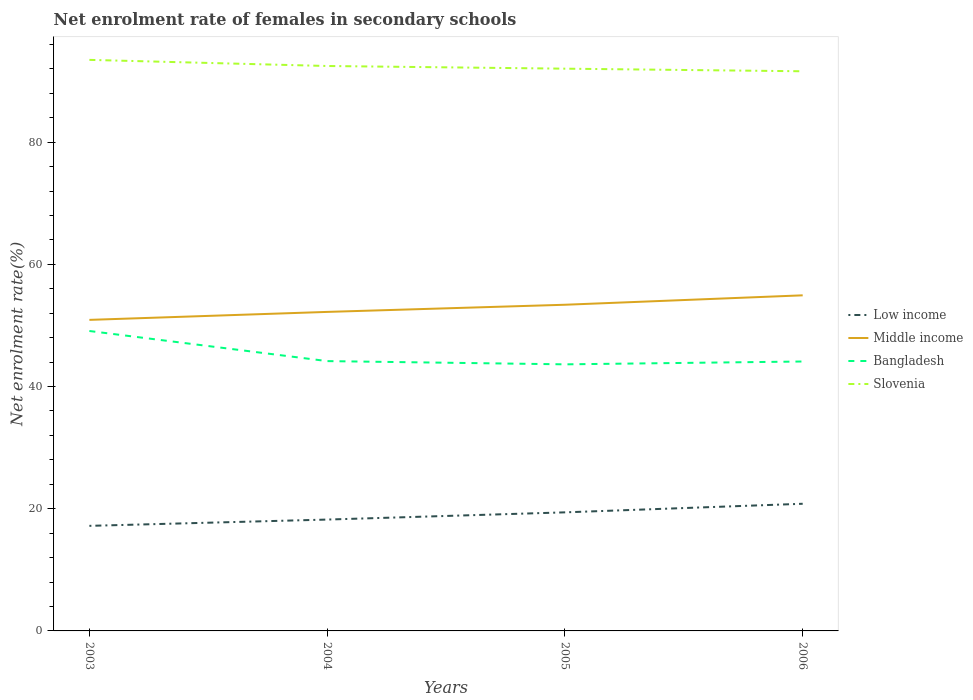Is the number of lines equal to the number of legend labels?
Your response must be concise. Yes. Across all years, what is the maximum net enrolment rate of females in secondary schools in Low income?
Offer a terse response. 17.2. In which year was the net enrolment rate of females in secondary schools in Slovenia maximum?
Your answer should be compact. 2006. What is the total net enrolment rate of females in secondary schools in Bangladesh in the graph?
Give a very brief answer. -0.46. What is the difference between the highest and the second highest net enrolment rate of females in secondary schools in Low income?
Make the answer very short. 3.61. What is the difference between the highest and the lowest net enrolment rate of females in secondary schools in Bangladesh?
Make the answer very short. 1. Is the net enrolment rate of females in secondary schools in Middle income strictly greater than the net enrolment rate of females in secondary schools in Bangladesh over the years?
Your response must be concise. No. How many lines are there?
Your response must be concise. 4. How many years are there in the graph?
Your response must be concise. 4. What is the difference between two consecutive major ticks on the Y-axis?
Ensure brevity in your answer.  20. Does the graph contain grids?
Offer a terse response. No. What is the title of the graph?
Make the answer very short. Net enrolment rate of females in secondary schools. What is the label or title of the Y-axis?
Provide a short and direct response. Net enrolment rate(%). What is the Net enrolment rate(%) in Low income in 2003?
Offer a terse response. 17.2. What is the Net enrolment rate(%) of Middle income in 2003?
Your response must be concise. 50.91. What is the Net enrolment rate(%) in Bangladesh in 2003?
Offer a terse response. 49.09. What is the Net enrolment rate(%) of Slovenia in 2003?
Keep it short and to the point. 93.46. What is the Net enrolment rate(%) of Low income in 2004?
Offer a terse response. 18.23. What is the Net enrolment rate(%) of Middle income in 2004?
Your answer should be very brief. 52.21. What is the Net enrolment rate(%) in Bangladesh in 2004?
Make the answer very short. 44.16. What is the Net enrolment rate(%) in Slovenia in 2004?
Provide a succinct answer. 92.46. What is the Net enrolment rate(%) in Low income in 2005?
Provide a succinct answer. 19.41. What is the Net enrolment rate(%) in Middle income in 2005?
Give a very brief answer. 53.38. What is the Net enrolment rate(%) of Bangladesh in 2005?
Offer a very short reply. 43.63. What is the Net enrolment rate(%) in Slovenia in 2005?
Offer a very short reply. 92.02. What is the Net enrolment rate(%) in Low income in 2006?
Make the answer very short. 20.81. What is the Net enrolment rate(%) of Middle income in 2006?
Keep it short and to the point. 54.93. What is the Net enrolment rate(%) in Bangladesh in 2006?
Your response must be concise. 44.1. What is the Net enrolment rate(%) of Slovenia in 2006?
Keep it short and to the point. 91.6. Across all years, what is the maximum Net enrolment rate(%) of Low income?
Offer a very short reply. 20.81. Across all years, what is the maximum Net enrolment rate(%) of Middle income?
Make the answer very short. 54.93. Across all years, what is the maximum Net enrolment rate(%) in Bangladesh?
Your response must be concise. 49.09. Across all years, what is the maximum Net enrolment rate(%) in Slovenia?
Your answer should be compact. 93.46. Across all years, what is the minimum Net enrolment rate(%) in Low income?
Provide a short and direct response. 17.2. Across all years, what is the minimum Net enrolment rate(%) in Middle income?
Your response must be concise. 50.91. Across all years, what is the minimum Net enrolment rate(%) of Bangladesh?
Your answer should be compact. 43.63. Across all years, what is the minimum Net enrolment rate(%) in Slovenia?
Provide a short and direct response. 91.6. What is the total Net enrolment rate(%) of Low income in the graph?
Provide a short and direct response. 75.64. What is the total Net enrolment rate(%) of Middle income in the graph?
Keep it short and to the point. 211.43. What is the total Net enrolment rate(%) in Bangladesh in the graph?
Offer a terse response. 180.98. What is the total Net enrolment rate(%) in Slovenia in the graph?
Provide a short and direct response. 369.54. What is the difference between the Net enrolment rate(%) of Low income in 2003 and that in 2004?
Your answer should be very brief. -1.03. What is the difference between the Net enrolment rate(%) in Middle income in 2003 and that in 2004?
Your response must be concise. -1.3. What is the difference between the Net enrolment rate(%) of Bangladesh in 2003 and that in 2004?
Make the answer very short. 4.93. What is the difference between the Net enrolment rate(%) in Slovenia in 2003 and that in 2004?
Keep it short and to the point. 1. What is the difference between the Net enrolment rate(%) in Low income in 2003 and that in 2005?
Ensure brevity in your answer.  -2.21. What is the difference between the Net enrolment rate(%) in Middle income in 2003 and that in 2005?
Your response must be concise. -2.48. What is the difference between the Net enrolment rate(%) of Bangladesh in 2003 and that in 2005?
Ensure brevity in your answer.  5.46. What is the difference between the Net enrolment rate(%) in Slovenia in 2003 and that in 2005?
Make the answer very short. 1.44. What is the difference between the Net enrolment rate(%) in Low income in 2003 and that in 2006?
Ensure brevity in your answer.  -3.61. What is the difference between the Net enrolment rate(%) of Middle income in 2003 and that in 2006?
Your answer should be very brief. -4.02. What is the difference between the Net enrolment rate(%) in Bangladesh in 2003 and that in 2006?
Make the answer very short. 4.99. What is the difference between the Net enrolment rate(%) in Slovenia in 2003 and that in 2006?
Make the answer very short. 1.87. What is the difference between the Net enrolment rate(%) in Low income in 2004 and that in 2005?
Ensure brevity in your answer.  -1.18. What is the difference between the Net enrolment rate(%) in Middle income in 2004 and that in 2005?
Keep it short and to the point. -1.17. What is the difference between the Net enrolment rate(%) in Bangladesh in 2004 and that in 2005?
Offer a very short reply. 0.53. What is the difference between the Net enrolment rate(%) of Slovenia in 2004 and that in 2005?
Keep it short and to the point. 0.44. What is the difference between the Net enrolment rate(%) in Low income in 2004 and that in 2006?
Keep it short and to the point. -2.59. What is the difference between the Net enrolment rate(%) in Middle income in 2004 and that in 2006?
Offer a very short reply. -2.71. What is the difference between the Net enrolment rate(%) of Bangladesh in 2004 and that in 2006?
Your answer should be compact. 0.07. What is the difference between the Net enrolment rate(%) of Slovenia in 2004 and that in 2006?
Offer a very short reply. 0.86. What is the difference between the Net enrolment rate(%) in Low income in 2005 and that in 2006?
Your answer should be very brief. -1.41. What is the difference between the Net enrolment rate(%) of Middle income in 2005 and that in 2006?
Ensure brevity in your answer.  -1.54. What is the difference between the Net enrolment rate(%) of Bangladesh in 2005 and that in 2006?
Ensure brevity in your answer.  -0.46. What is the difference between the Net enrolment rate(%) in Slovenia in 2005 and that in 2006?
Your answer should be compact. 0.43. What is the difference between the Net enrolment rate(%) in Low income in 2003 and the Net enrolment rate(%) in Middle income in 2004?
Keep it short and to the point. -35.02. What is the difference between the Net enrolment rate(%) of Low income in 2003 and the Net enrolment rate(%) of Bangladesh in 2004?
Offer a very short reply. -26.96. What is the difference between the Net enrolment rate(%) of Low income in 2003 and the Net enrolment rate(%) of Slovenia in 2004?
Your answer should be very brief. -75.26. What is the difference between the Net enrolment rate(%) of Middle income in 2003 and the Net enrolment rate(%) of Bangladesh in 2004?
Your answer should be compact. 6.75. What is the difference between the Net enrolment rate(%) of Middle income in 2003 and the Net enrolment rate(%) of Slovenia in 2004?
Make the answer very short. -41.55. What is the difference between the Net enrolment rate(%) of Bangladesh in 2003 and the Net enrolment rate(%) of Slovenia in 2004?
Provide a short and direct response. -43.37. What is the difference between the Net enrolment rate(%) of Low income in 2003 and the Net enrolment rate(%) of Middle income in 2005?
Provide a succinct answer. -36.19. What is the difference between the Net enrolment rate(%) of Low income in 2003 and the Net enrolment rate(%) of Bangladesh in 2005?
Offer a terse response. -26.43. What is the difference between the Net enrolment rate(%) in Low income in 2003 and the Net enrolment rate(%) in Slovenia in 2005?
Provide a short and direct response. -74.83. What is the difference between the Net enrolment rate(%) in Middle income in 2003 and the Net enrolment rate(%) in Bangladesh in 2005?
Give a very brief answer. 7.28. What is the difference between the Net enrolment rate(%) of Middle income in 2003 and the Net enrolment rate(%) of Slovenia in 2005?
Provide a short and direct response. -41.11. What is the difference between the Net enrolment rate(%) in Bangladesh in 2003 and the Net enrolment rate(%) in Slovenia in 2005?
Provide a succinct answer. -42.93. What is the difference between the Net enrolment rate(%) of Low income in 2003 and the Net enrolment rate(%) of Middle income in 2006?
Make the answer very short. -37.73. What is the difference between the Net enrolment rate(%) in Low income in 2003 and the Net enrolment rate(%) in Bangladesh in 2006?
Provide a short and direct response. -26.9. What is the difference between the Net enrolment rate(%) of Low income in 2003 and the Net enrolment rate(%) of Slovenia in 2006?
Ensure brevity in your answer.  -74.4. What is the difference between the Net enrolment rate(%) of Middle income in 2003 and the Net enrolment rate(%) of Bangladesh in 2006?
Give a very brief answer. 6.81. What is the difference between the Net enrolment rate(%) in Middle income in 2003 and the Net enrolment rate(%) in Slovenia in 2006?
Provide a short and direct response. -40.69. What is the difference between the Net enrolment rate(%) in Bangladesh in 2003 and the Net enrolment rate(%) in Slovenia in 2006?
Your response must be concise. -42.51. What is the difference between the Net enrolment rate(%) in Low income in 2004 and the Net enrolment rate(%) in Middle income in 2005?
Keep it short and to the point. -35.16. What is the difference between the Net enrolment rate(%) of Low income in 2004 and the Net enrolment rate(%) of Bangladesh in 2005?
Provide a short and direct response. -25.41. What is the difference between the Net enrolment rate(%) of Low income in 2004 and the Net enrolment rate(%) of Slovenia in 2005?
Keep it short and to the point. -73.8. What is the difference between the Net enrolment rate(%) of Middle income in 2004 and the Net enrolment rate(%) of Bangladesh in 2005?
Offer a terse response. 8.58. What is the difference between the Net enrolment rate(%) in Middle income in 2004 and the Net enrolment rate(%) in Slovenia in 2005?
Make the answer very short. -39.81. What is the difference between the Net enrolment rate(%) in Bangladesh in 2004 and the Net enrolment rate(%) in Slovenia in 2005?
Provide a short and direct response. -47.86. What is the difference between the Net enrolment rate(%) in Low income in 2004 and the Net enrolment rate(%) in Middle income in 2006?
Offer a very short reply. -36.7. What is the difference between the Net enrolment rate(%) in Low income in 2004 and the Net enrolment rate(%) in Bangladesh in 2006?
Provide a succinct answer. -25.87. What is the difference between the Net enrolment rate(%) of Low income in 2004 and the Net enrolment rate(%) of Slovenia in 2006?
Offer a terse response. -73.37. What is the difference between the Net enrolment rate(%) of Middle income in 2004 and the Net enrolment rate(%) of Bangladesh in 2006?
Keep it short and to the point. 8.12. What is the difference between the Net enrolment rate(%) of Middle income in 2004 and the Net enrolment rate(%) of Slovenia in 2006?
Provide a short and direct response. -39.38. What is the difference between the Net enrolment rate(%) in Bangladesh in 2004 and the Net enrolment rate(%) in Slovenia in 2006?
Provide a short and direct response. -47.44. What is the difference between the Net enrolment rate(%) of Low income in 2005 and the Net enrolment rate(%) of Middle income in 2006?
Ensure brevity in your answer.  -35.52. What is the difference between the Net enrolment rate(%) in Low income in 2005 and the Net enrolment rate(%) in Bangladesh in 2006?
Provide a short and direct response. -24.69. What is the difference between the Net enrolment rate(%) of Low income in 2005 and the Net enrolment rate(%) of Slovenia in 2006?
Provide a succinct answer. -72.19. What is the difference between the Net enrolment rate(%) in Middle income in 2005 and the Net enrolment rate(%) in Bangladesh in 2006?
Your answer should be very brief. 9.29. What is the difference between the Net enrolment rate(%) of Middle income in 2005 and the Net enrolment rate(%) of Slovenia in 2006?
Keep it short and to the point. -38.21. What is the difference between the Net enrolment rate(%) in Bangladesh in 2005 and the Net enrolment rate(%) in Slovenia in 2006?
Your response must be concise. -47.97. What is the average Net enrolment rate(%) of Low income per year?
Give a very brief answer. 18.91. What is the average Net enrolment rate(%) of Middle income per year?
Your answer should be very brief. 52.86. What is the average Net enrolment rate(%) in Bangladesh per year?
Your response must be concise. 45.24. What is the average Net enrolment rate(%) in Slovenia per year?
Make the answer very short. 92.39. In the year 2003, what is the difference between the Net enrolment rate(%) in Low income and Net enrolment rate(%) in Middle income?
Your response must be concise. -33.71. In the year 2003, what is the difference between the Net enrolment rate(%) of Low income and Net enrolment rate(%) of Bangladesh?
Provide a short and direct response. -31.89. In the year 2003, what is the difference between the Net enrolment rate(%) of Low income and Net enrolment rate(%) of Slovenia?
Keep it short and to the point. -76.26. In the year 2003, what is the difference between the Net enrolment rate(%) of Middle income and Net enrolment rate(%) of Bangladesh?
Your answer should be compact. 1.82. In the year 2003, what is the difference between the Net enrolment rate(%) of Middle income and Net enrolment rate(%) of Slovenia?
Offer a very short reply. -42.55. In the year 2003, what is the difference between the Net enrolment rate(%) in Bangladesh and Net enrolment rate(%) in Slovenia?
Ensure brevity in your answer.  -44.37. In the year 2004, what is the difference between the Net enrolment rate(%) in Low income and Net enrolment rate(%) in Middle income?
Offer a terse response. -33.99. In the year 2004, what is the difference between the Net enrolment rate(%) of Low income and Net enrolment rate(%) of Bangladesh?
Your response must be concise. -25.94. In the year 2004, what is the difference between the Net enrolment rate(%) in Low income and Net enrolment rate(%) in Slovenia?
Provide a succinct answer. -74.24. In the year 2004, what is the difference between the Net enrolment rate(%) of Middle income and Net enrolment rate(%) of Bangladesh?
Your response must be concise. 8.05. In the year 2004, what is the difference between the Net enrolment rate(%) of Middle income and Net enrolment rate(%) of Slovenia?
Offer a terse response. -40.25. In the year 2004, what is the difference between the Net enrolment rate(%) of Bangladesh and Net enrolment rate(%) of Slovenia?
Your response must be concise. -48.3. In the year 2005, what is the difference between the Net enrolment rate(%) in Low income and Net enrolment rate(%) in Middle income?
Provide a succinct answer. -33.98. In the year 2005, what is the difference between the Net enrolment rate(%) of Low income and Net enrolment rate(%) of Bangladesh?
Keep it short and to the point. -24.22. In the year 2005, what is the difference between the Net enrolment rate(%) of Low income and Net enrolment rate(%) of Slovenia?
Provide a short and direct response. -72.62. In the year 2005, what is the difference between the Net enrolment rate(%) of Middle income and Net enrolment rate(%) of Bangladesh?
Your response must be concise. 9.75. In the year 2005, what is the difference between the Net enrolment rate(%) of Middle income and Net enrolment rate(%) of Slovenia?
Provide a short and direct response. -38.64. In the year 2005, what is the difference between the Net enrolment rate(%) in Bangladesh and Net enrolment rate(%) in Slovenia?
Offer a very short reply. -48.39. In the year 2006, what is the difference between the Net enrolment rate(%) in Low income and Net enrolment rate(%) in Middle income?
Offer a very short reply. -34.11. In the year 2006, what is the difference between the Net enrolment rate(%) in Low income and Net enrolment rate(%) in Bangladesh?
Your response must be concise. -23.28. In the year 2006, what is the difference between the Net enrolment rate(%) in Low income and Net enrolment rate(%) in Slovenia?
Your response must be concise. -70.79. In the year 2006, what is the difference between the Net enrolment rate(%) in Middle income and Net enrolment rate(%) in Bangladesh?
Keep it short and to the point. 10.83. In the year 2006, what is the difference between the Net enrolment rate(%) in Middle income and Net enrolment rate(%) in Slovenia?
Provide a succinct answer. -36.67. In the year 2006, what is the difference between the Net enrolment rate(%) of Bangladesh and Net enrolment rate(%) of Slovenia?
Your answer should be very brief. -47.5. What is the ratio of the Net enrolment rate(%) of Low income in 2003 to that in 2004?
Make the answer very short. 0.94. What is the ratio of the Net enrolment rate(%) in Bangladesh in 2003 to that in 2004?
Your answer should be compact. 1.11. What is the ratio of the Net enrolment rate(%) in Slovenia in 2003 to that in 2004?
Offer a terse response. 1.01. What is the ratio of the Net enrolment rate(%) of Low income in 2003 to that in 2005?
Offer a very short reply. 0.89. What is the ratio of the Net enrolment rate(%) in Middle income in 2003 to that in 2005?
Ensure brevity in your answer.  0.95. What is the ratio of the Net enrolment rate(%) in Bangladesh in 2003 to that in 2005?
Offer a terse response. 1.13. What is the ratio of the Net enrolment rate(%) in Slovenia in 2003 to that in 2005?
Ensure brevity in your answer.  1.02. What is the ratio of the Net enrolment rate(%) in Low income in 2003 to that in 2006?
Make the answer very short. 0.83. What is the ratio of the Net enrolment rate(%) in Middle income in 2003 to that in 2006?
Provide a short and direct response. 0.93. What is the ratio of the Net enrolment rate(%) in Bangladesh in 2003 to that in 2006?
Give a very brief answer. 1.11. What is the ratio of the Net enrolment rate(%) of Slovenia in 2003 to that in 2006?
Make the answer very short. 1.02. What is the ratio of the Net enrolment rate(%) in Low income in 2004 to that in 2005?
Give a very brief answer. 0.94. What is the ratio of the Net enrolment rate(%) in Middle income in 2004 to that in 2005?
Your response must be concise. 0.98. What is the ratio of the Net enrolment rate(%) in Bangladesh in 2004 to that in 2005?
Keep it short and to the point. 1.01. What is the ratio of the Net enrolment rate(%) in Low income in 2004 to that in 2006?
Offer a terse response. 0.88. What is the ratio of the Net enrolment rate(%) in Middle income in 2004 to that in 2006?
Your answer should be compact. 0.95. What is the ratio of the Net enrolment rate(%) of Slovenia in 2004 to that in 2006?
Make the answer very short. 1.01. What is the ratio of the Net enrolment rate(%) in Low income in 2005 to that in 2006?
Give a very brief answer. 0.93. What is the ratio of the Net enrolment rate(%) in Middle income in 2005 to that in 2006?
Make the answer very short. 0.97. What is the ratio of the Net enrolment rate(%) of Bangladesh in 2005 to that in 2006?
Make the answer very short. 0.99. What is the difference between the highest and the second highest Net enrolment rate(%) of Low income?
Offer a very short reply. 1.41. What is the difference between the highest and the second highest Net enrolment rate(%) of Middle income?
Provide a succinct answer. 1.54. What is the difference between the highest and the second highest Net enrolment rate(%) of Bangladesh?
Ensure brevity in your answer.  4.93. What is the difference between the highest and the lowest Net enrolment rate(%) of Low income?
Your answer should be compact. 3.61. What is the difference between the highest and the lowest Net enrolment rate(%) of Middle income?
Give a very brief answer. 4.02. What is the difference between the highest and the lowest Net enrolment rate(%) in Bangladesh?
Ensure brevity in your answer.  5.46. What is the difference between the highest and the lowest Net enrolment rate(%) of Slovenia?
Provide a succinct answer. 1.87. 